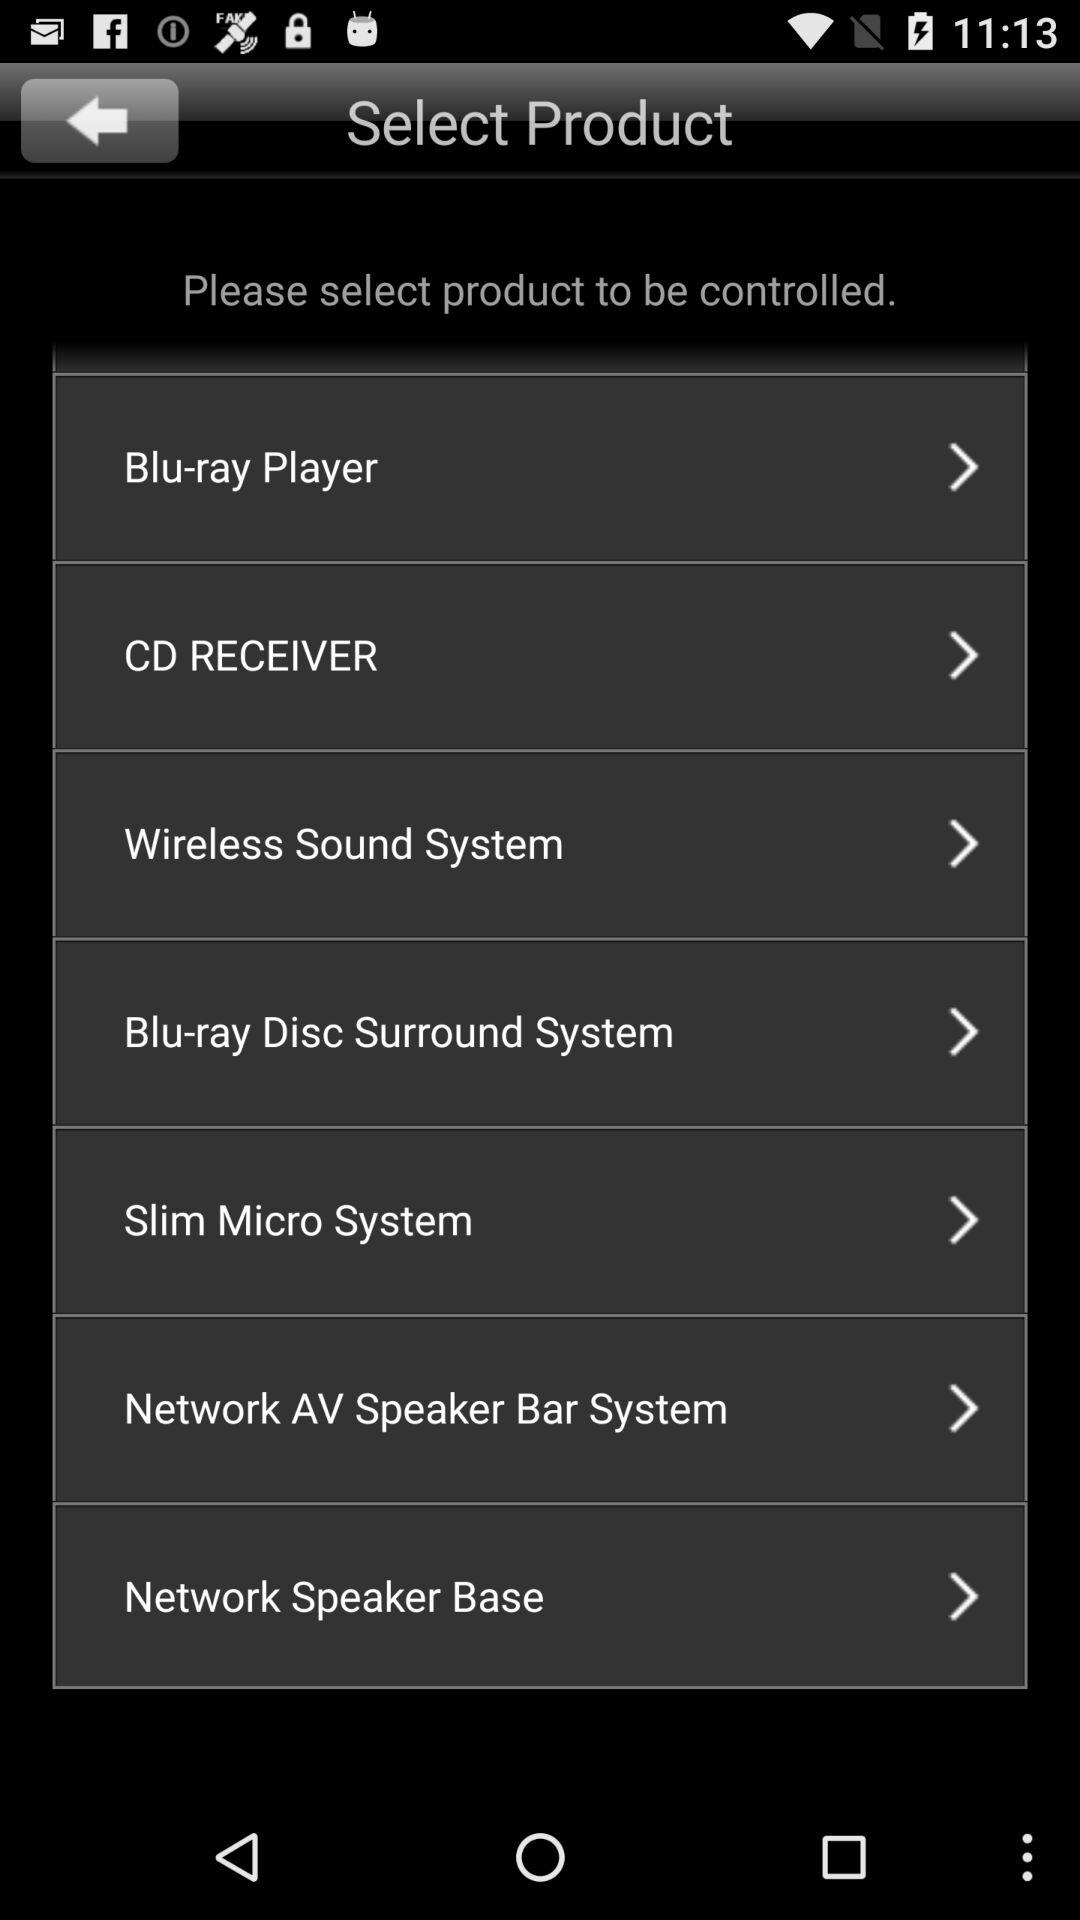Which product has been selected?
When the provided information is insufficient, respond with <no answer>. <no answer> 